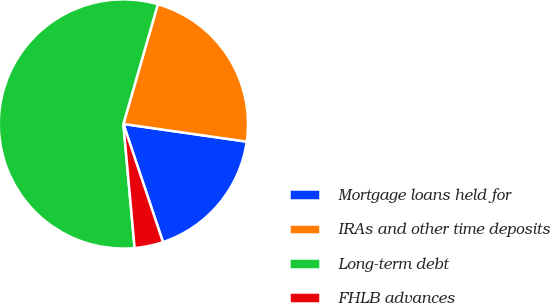<chart> <loc_0><loc_0><loc_500><loc_500><pie_chart><fcel>Mortgage loans held for<fcel>IRAs and other time deposits<fcel>Long-term debt<fcel>FHLB advances<nl><fcel>17.59%<fcel>22.81%<fcel>55.9%<fcel>3.71%<nl></chart> 